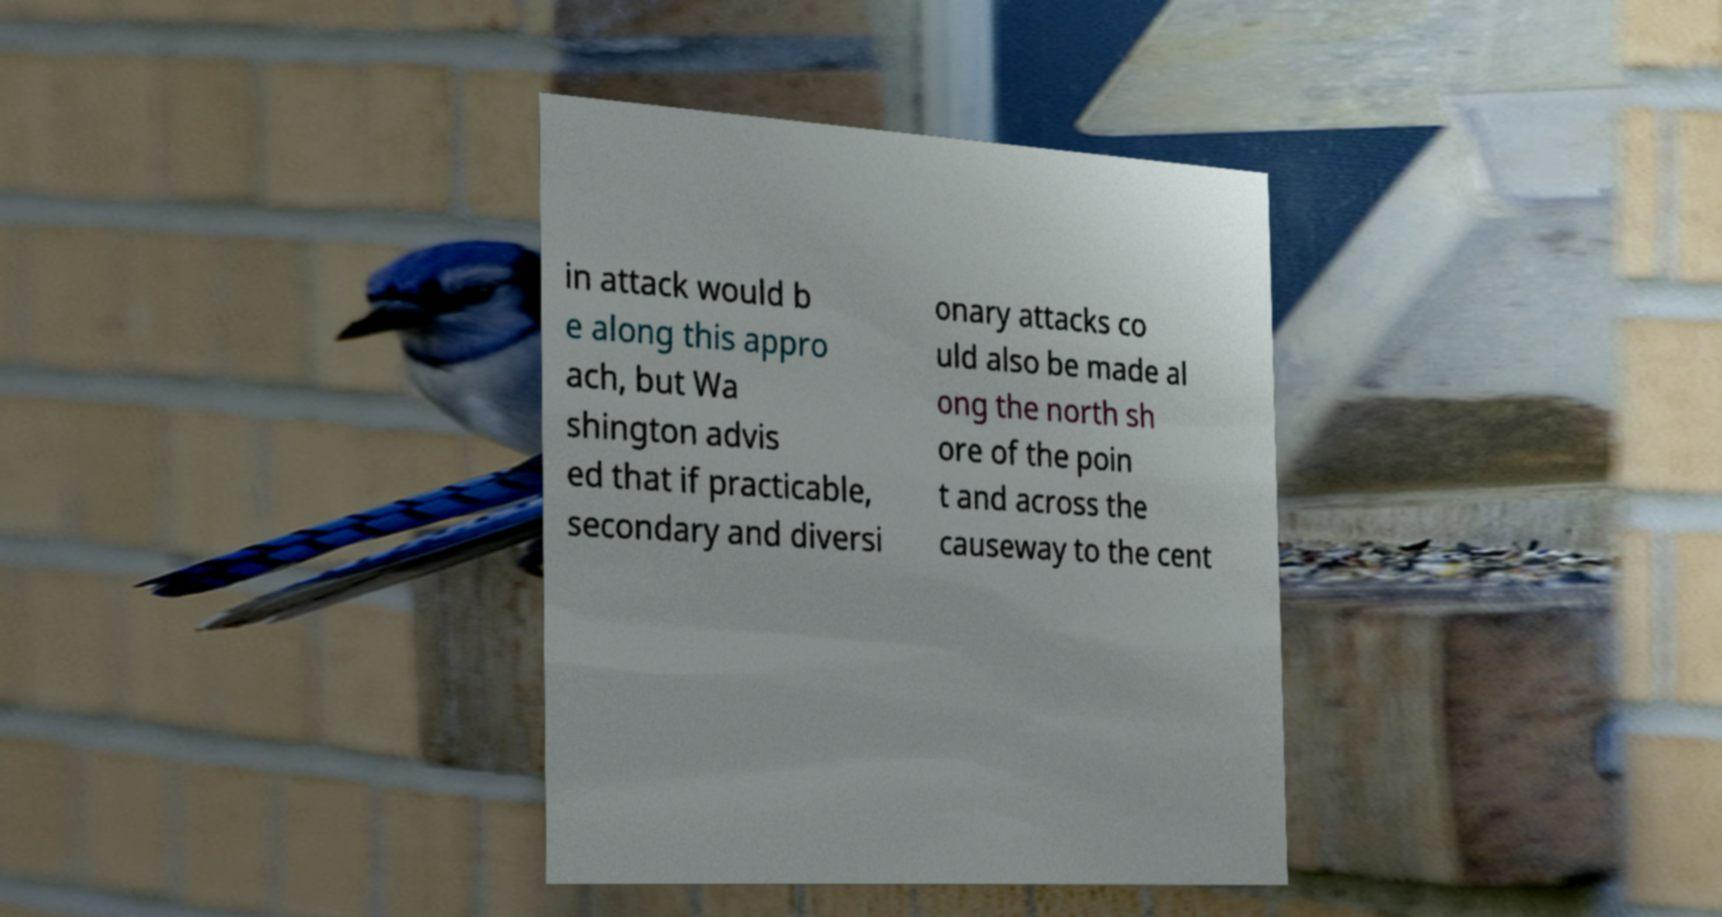Can you read and provide the text displayed in the image?This photo seems to have some interesting text. Can you extract and type it out for me? in attack would b e along this appro ach, but Wa shington advis ed that if practicable, secondary and diversi onary attacks co uld also be made al ong the north sh ore of the poin t and across the causeway to the cent 